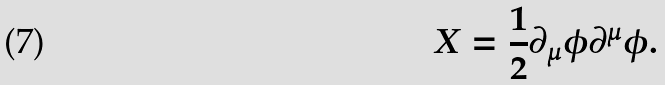Convert formula to latex. <formula><loc_0><loc_0><loc_500><loc_500>X = \frac { 1 } { 2 } \partial _ { \mu } \phi \partial ^ { \mu } \phi .</formula> 